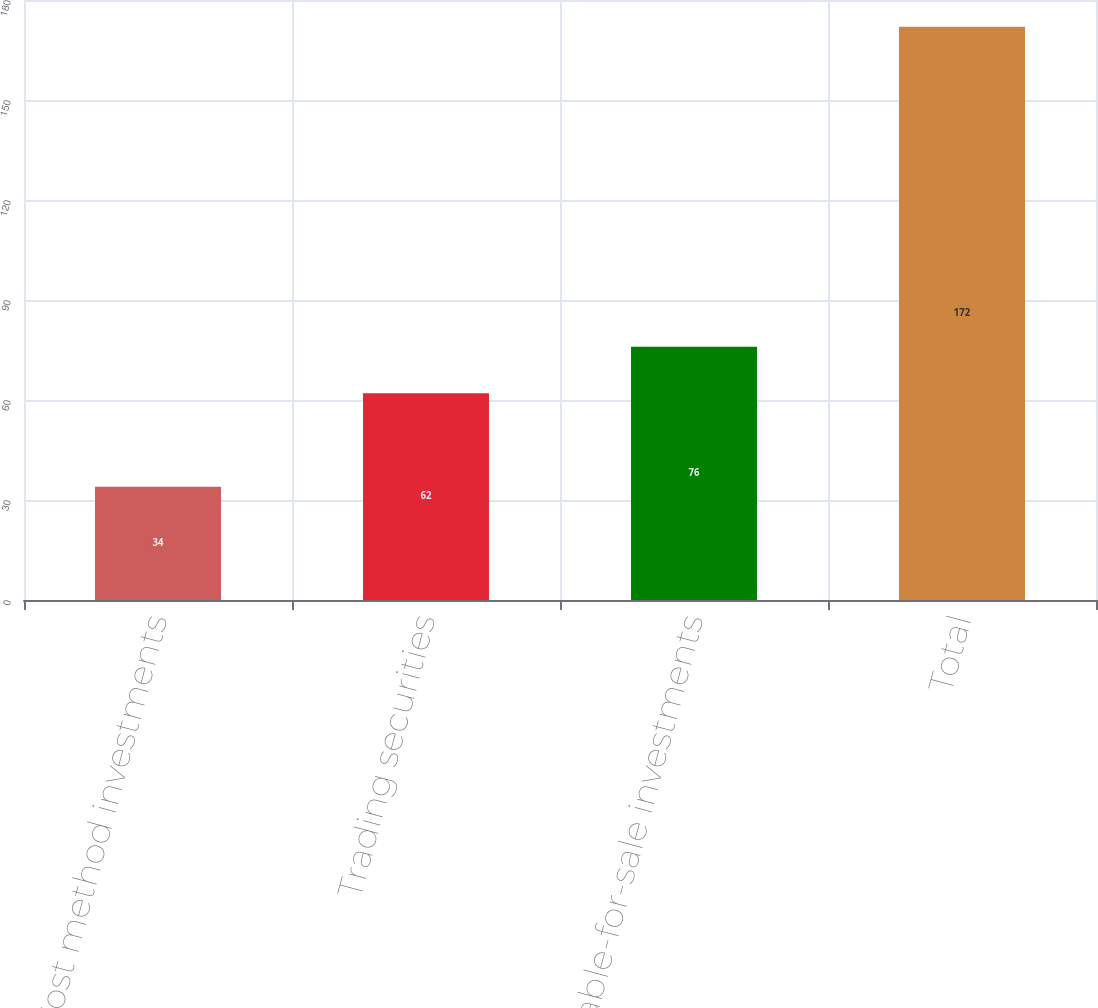Convert chart to OTSL. <chart><loc_0><loc_0><loc_500><loc_500><bar_chart><fcel>Cost method investments<fcel>Trading securities<fcel>Available-for-sale investments<fcel>Total<nl><fcel>34<fcel>62<fcel>76<fcel>172<nl></chart> 